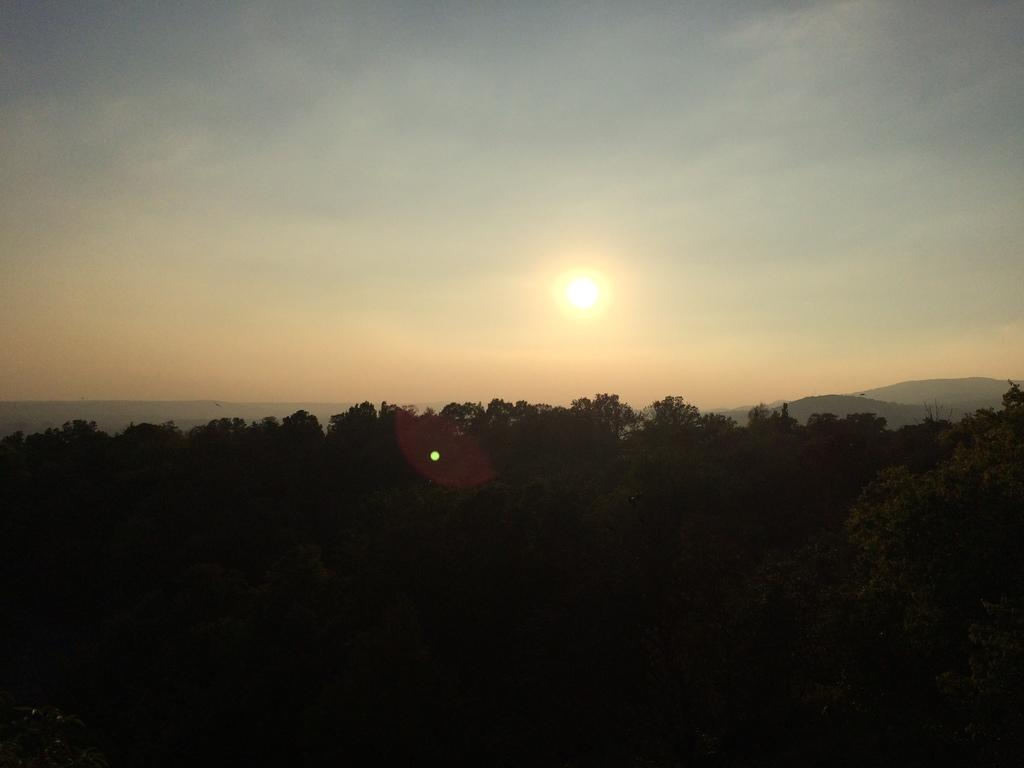What type of vegetation is at the bottom of the image? There are trees at the bottom of the image. What type of natural landform can be seen in the background of the image? There are mountains in the background of the image. What is visible at the top of the image? The sky is visible at the top of the image. What celestial body is present in the sky? The sun is present in the sky. What year is depicted in the image? The image does not depict a specific year; it is a landscape featuring trees, mountains, sky, and the sun. What type of coach can be seen in the image? There is no coach present in the image. 